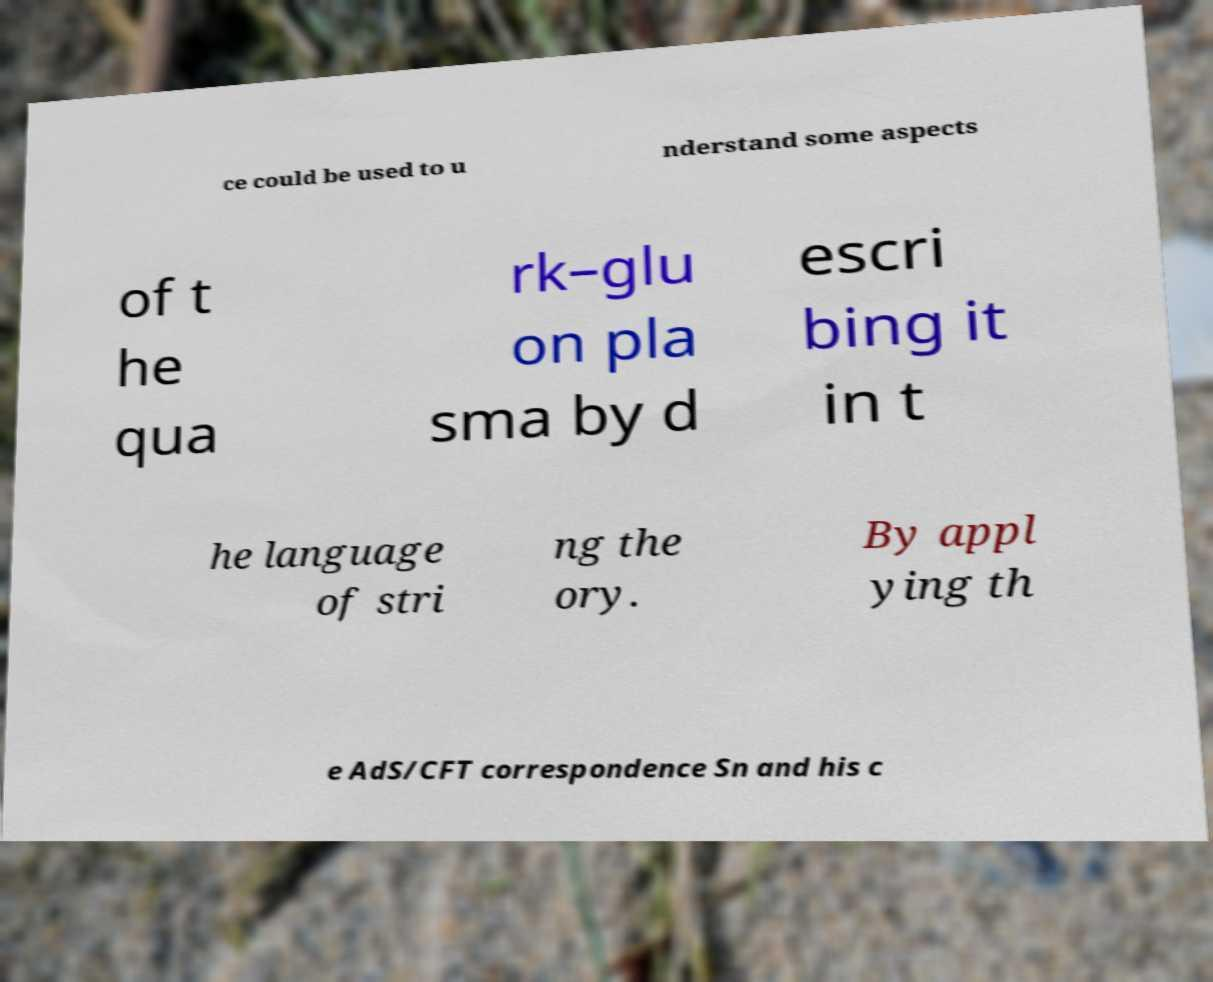Could you assist in decoding the text presented in this image and type it out clearly? ce could be used to u nderstand some aspects of t he qua rk–glu on pla sma by d escri bing it in t he language of stri ng the ory. By appl ying th e AdS/CFT correspondence Sn and his c 